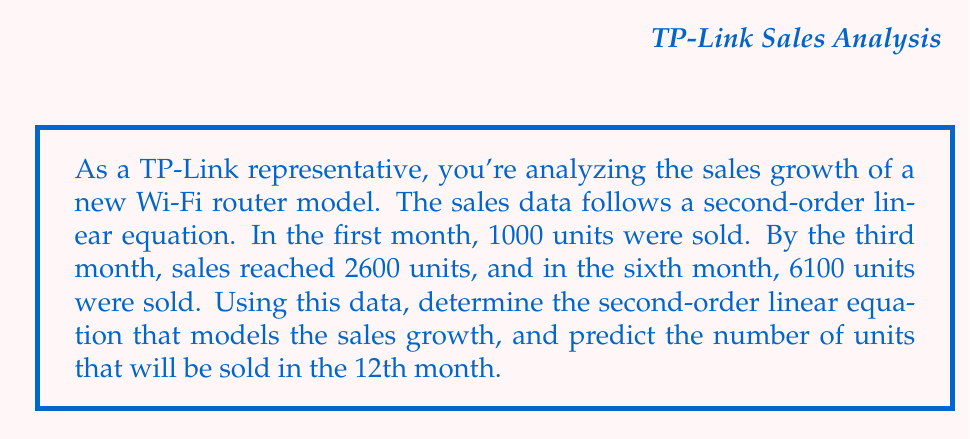Help me with this question. Let's approach this step-by-step:

1) We'll use the general form of a second-order linear equation:
   $$ y = ax^2 + bx + c $$
   where $y$ represents the number of units sold and $x$ represents the month number.

2) We have three data points:
   $(1, 1000)$, $(3, 2600)$, and $(6, 6100)$

3) Substituting these into our equation:
   $$ 1000 = a(1)^2 + b(1) + c $$
   $$ 2600 = a(3)^2 + b(3) + c $$
   $$ 6100 = a(6)^2 + b(6) + c $$

4) Simplifying:
   $$ 1000 = a + b + c \quad (1)$$
   $$ 2600 = 9a + 3b + c \quad (2)$$
   $$ 6100 = 36a + 6b + c \quad (3)$$

5) Subtracting (1) from (2):
   $$ 1600 = 8a + 2b \quad (4)$$

6) Subtracting (1) from (3):
   $$ 5100 = 35a + 5b \quad (5)$$

7) Multiplying (4) by 5 and (5) by 2:
   $$ 8000 = 40a + 10b $$
   $$ 10200 = 70a + 10b $$

8) Subtracting these:
   $$ -2200 = -30a $$
   $$ a = \frac{2200}{30} = \frac{220}{3} \approx 73.33 $$

9) Substituting this back into (4):
   $$ 1600 = 8(\frac{220}{3}) + 2b $$
   $$ 1600 = \frac{1760}{3} + 2b $$
   $$ b = \frac{1600 \cdot 3 - 1760}{2 \cdot 3} = \frac{3040}{6} = \frac{1520}{3} \approx 506.67 $$

10) Finally, using (1):
    $$ c = 1000 - a - b = 1000 - \frac{220}{3} - \frac{1520}{3} = \frac{3000 - 220 - 1520}{3} = \frac{1260}{3} = 420 $$

11) Therefore, our equation is:
    $$ y = \frac{220}{3}x^2 + \frac{1520}{3}x + 420 $$

12) To predict sales for the 12th month, we substitute $x = 12$:
    $$ y = \frac{220}{3}(12)^2 + \frac{1520}{3}(12) + 420 $$
    $$ y = \frac{220 \cdot 144}{3} + \frac{1520 \cdot 12}{3} + 420 $$
    $$ y = 10560 + 6080 + 420 = 17060 $$
Answer: The second-order linear equation modeling the sales growth is:
$$ y = \frac{220}{3}x^2 + \frac{1520}{3}x + 420 $$
The predicted number of units to be sold in the 12th month is 17,060. 